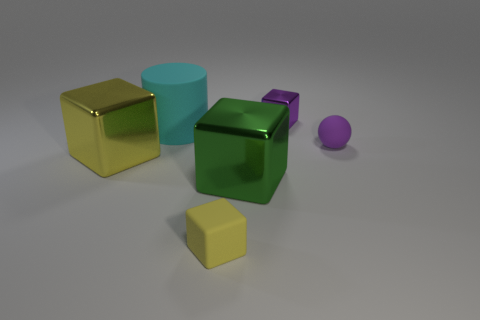Add 1 big cyan rubber cylinders. How many objects exist? 7 Subtract all yellow cylinders. Subtract all blue blocks. How many cylinders are left? 1 Subtract all cylinders. How many objects are left? 5 Add 2 purple balls. How many purple balls are left? 3 Add 6 purple matte things. How many purple matte things exist? 7 Subtract 0 red cylinders. How many objects are left? 6 Subtract all small purple rubber spheres. Subtract all big cyan rubber things. How many objects are left? 4 